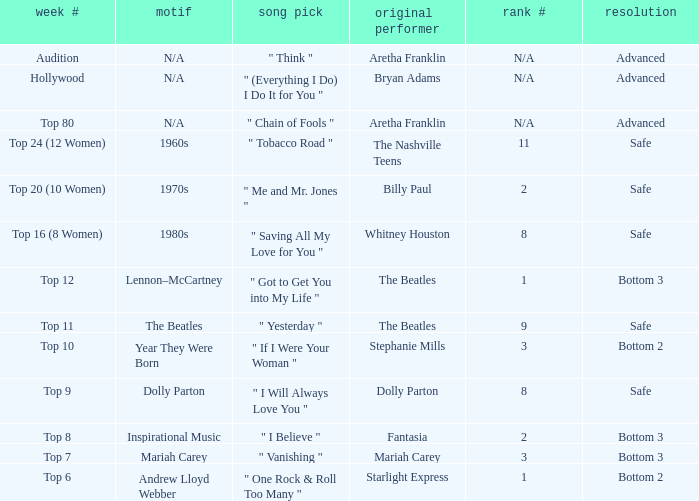Name the song choice when week number is hollywood " (Everything I Do) I Do It for You ". 